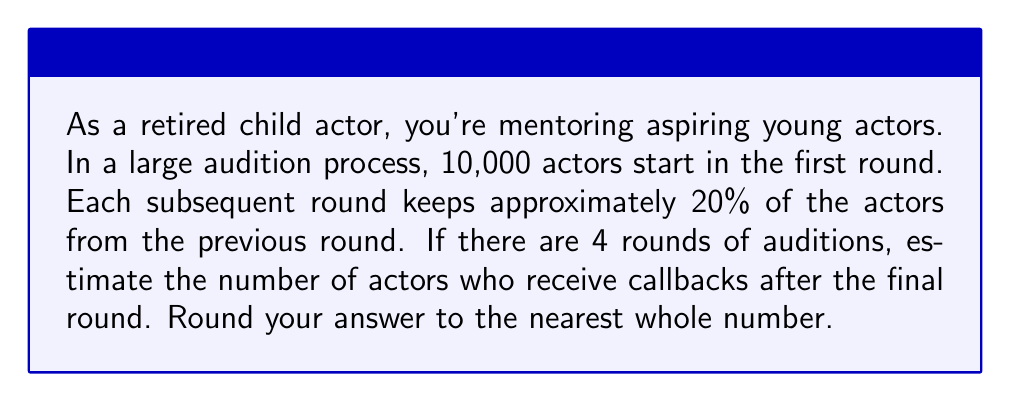Give your solution to this math problem. Let's approach this step-by-step using exponents:

1) We start with 10,000 actors in the first round.

2) Each round keeps 20% of the actors, which is equivalent to multiplying by 0.2.

3) We have 4 rounds in total, so we need to apply this 20% reduction 3 times (as the first round is the starting point).

4) We can express this mathematically as:

   $$ 10,000 \times (0.2)^3 $$

5) Let's calculate:
   $$ 10,000 \times (0.2)^3 = 10,000 \times 0.008 = 80 $$

6) Therefore, the estimated number of actors receiving callbacks after the final round is 80.

This problem demonstrates how quickly numbers can decrease when repeatedly taking a fraction (in this case, 20%) of the previous amount, which is a common scenario in multi-round audition processes.
Answer: 80 actors 